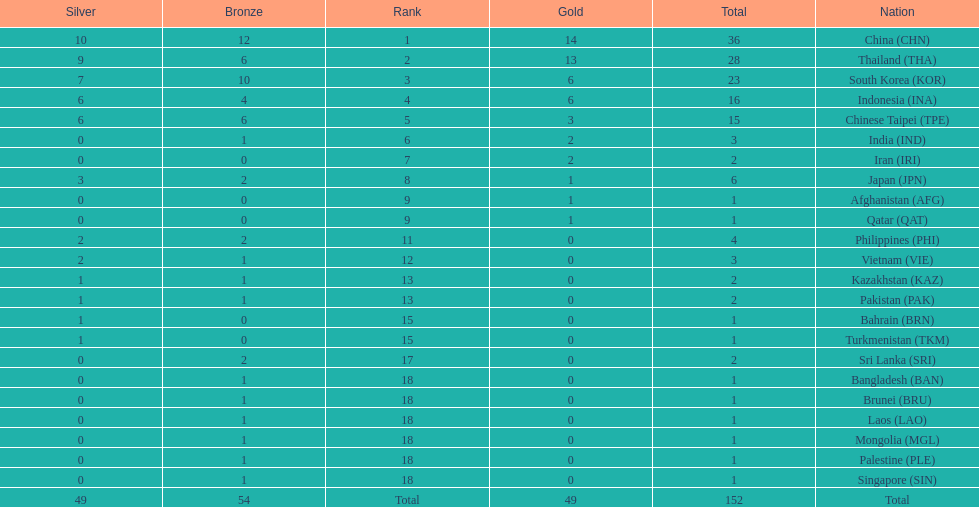How many combined silver medals did china, india, and japan earn ? 13. 